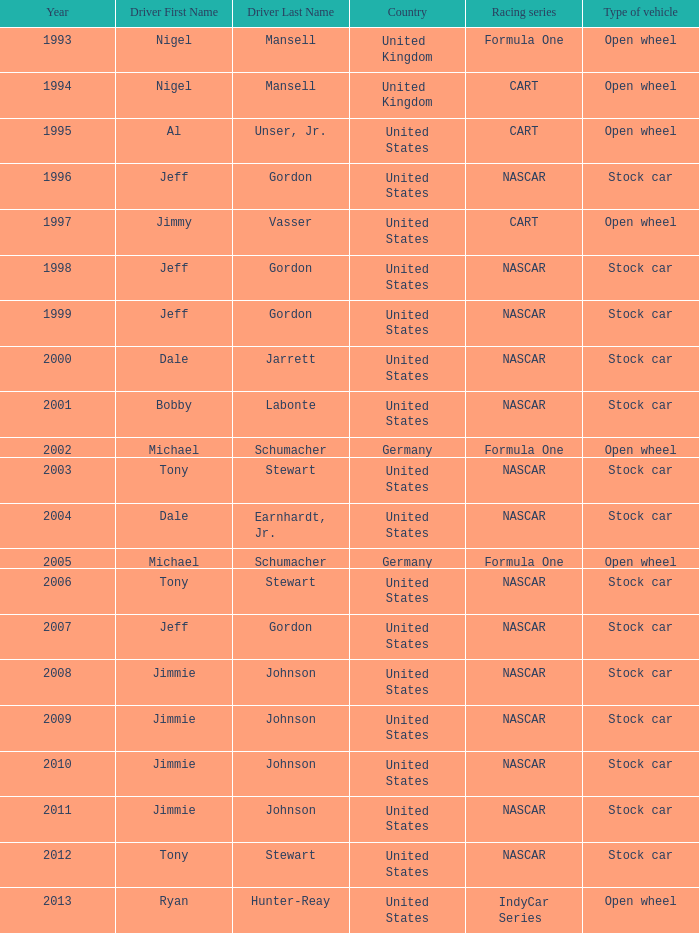What Nation of citizenship has a stock car vehicle with a year of 2012? United States. 